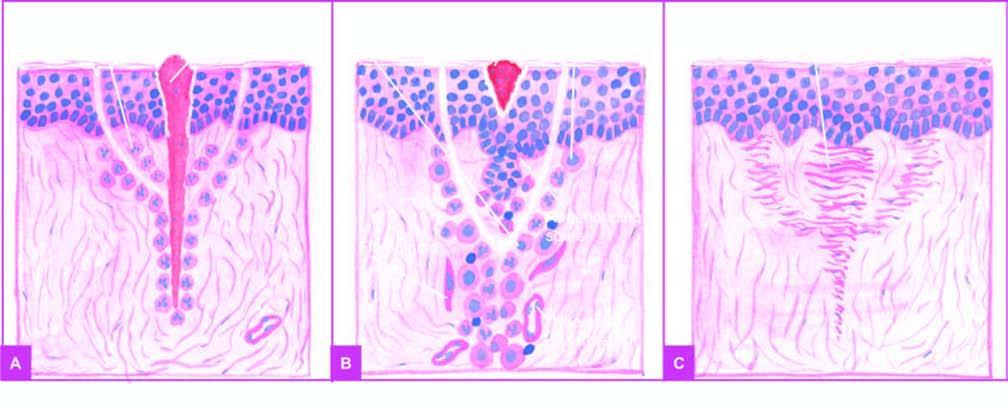does c result around 7th day result in scar tissue at the sites of incision and suture track?
Answer the question using a single word or phrase. No 